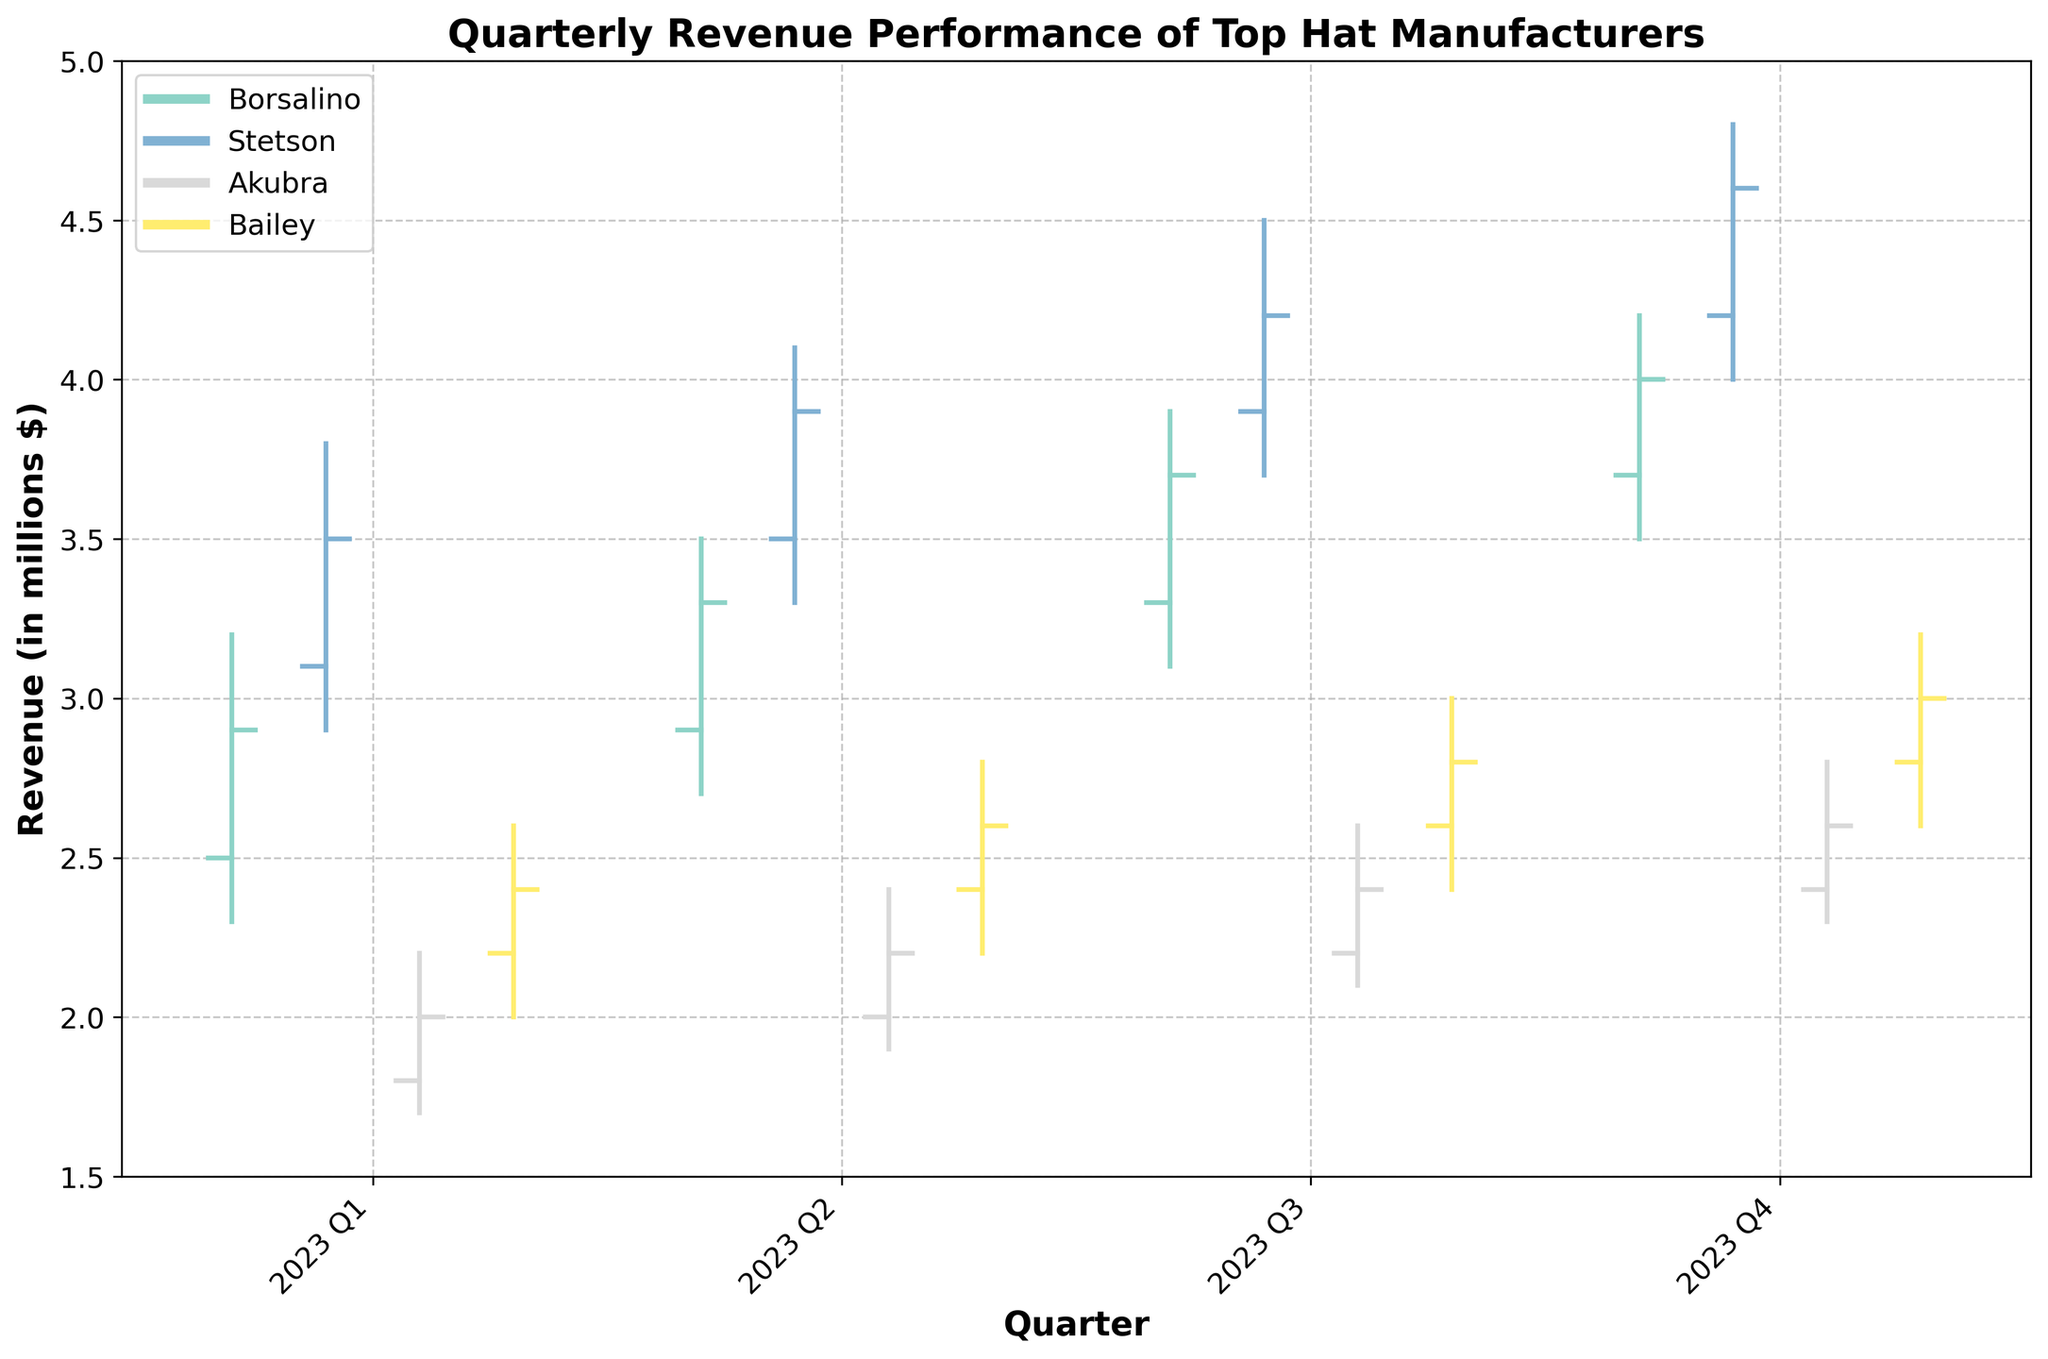What is the title of the chart? The title of the chart is prominently displayed at the top and provides an overview of what the chart represents.
Answer: Quarterly Revenue Performance of Top Hat Manufacturers Which manufacturer had the highest closing revenue in 2023 Q4? The highest closing revenue for each manufacturer in 2023 Q4 is represented by the last horizontal bar for each color. Stetson has the highest, which closes at $4.6 million.
Answer: Stetson What is the range of revenue for Borsalino in 2023 Q2? The range is calculated by subtracting the lowest revenue value from the highest revenue value. For Borsalino in Q2, the highest revenue is $3.5 million, and the lowest is $2.7 million, so the range is $3.5 million - $2.7 million.
Answer: 0.8 million How does Bailey's closing revenue in 2023 Q3 compare to its opening revenue in 2023 Q1? Bailey's closing revenue in Q3 can be directly compared to the opening revenue in Q1. Bailey closed at $2.8 million in Q3 and opened at $2.2 million in Q1.
Answer: Higher Which manufacturer showed the highest increase in closing revenue from 2023 Q1 to 2023 Q2? The increase in closing revenue is calculated by subtracting the Q1 closing revenue from the Q2 closing revenue for each manufacturer. Stetson showed the highest increase from $3.5 million in Q1 to $3.9 million in Q2, increasing by $0.4 million.
Answer: Stetson What is the overall trend for Akubra's closing revenue across all quarters in 2023? Observing the closing revenue for Akubra across 2023 Q1 to Q4, it fairly consistently increases quarter by quarter: $2.0 million, $2.2 million, $2.4 million, and $2.6 million respectively.
Answer: Increasing Between Borsalino and Bailey, which manufacturer had a higher low revenue in 2023 Q3? Checking the low revenue markers for Borsalino and Bailey in 2023 Q3, Borsalino's lowest revenue was $3.1 million and Bailey's was $2.4 million.
Answer: Borsalino What is the difference between the highest and lowest revenue for Stetson in 2023 Q4? The difference is calculated by subtracting the lowest revenue from the highest. Stetson's highest revenue in Q4 is $4.8 million, and the lowest is $4.0 million.
Answer: 0.8 million What is the average closing revenue for all manufacturers in 2023 Q1? To find the average, sum the closing revenues for all manufacturers in 2023 Q1 and then divide by the number of manufacturers. The sum is $2.9 + $3.5 + $2.0 + $2.4 = $10.8 million, and there are 4 manufacturers. The average closing revenue is $10.8 million/4.
Answer: 2.7 million 